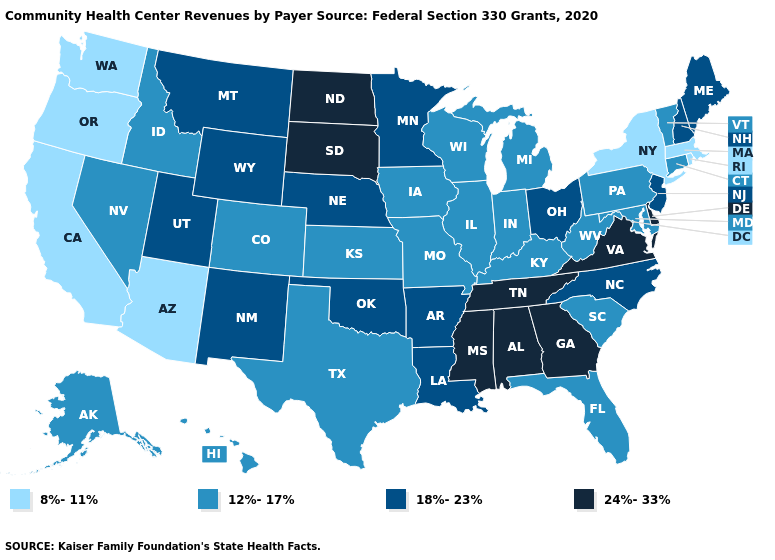Name the states that have a value in the range 12%-17%?
Concise answer only. Alaska, Colorado, Connecticut, Florida, Hawaii, Idaho, Illinois, Indiana, Iowa, Kansas, Kentucky, Maryland, Michigan, Missouri, Nevada, Pennsylvania, South Carolina, Texas, Vermont, West Virginia, Wisconsin. Among the states that border Illinois , which have the lowest value?
Answer briefly. Indiana, Iowa, Kentucky, Missouri, Wisconsin. Does Missouri have the same value as Colorado?
Short answer required. Yes. Name the states that have a value in the range 24%-33%?
Write a very short answer. Alabama, Delaware, Georgia, Mississippi, North Dakota, South Dakota, Tennessee, Virginia. What is the lowest value in the USA?
Quick response, please. 8%-11%. What is the value of Colorado?
Write a very short answer. 12%-17%. Name the states that have a value in the range 8%-11%?
Give a very brief answer. Arizona, California, Massachusetts, New York, Oregon, Rhode Island, Washington. What is the value of Oregon?
Write a very short answer. 8%-11%. Name the states that have a value in the range 24%-33%?
Quick response, please. Alabama, Delaware, Georgia, Mississippi, North Dakota, South Dakota, Tennessee, Virginia. Which states have the highest value in the USA?
Write a very short answer. Alabama, Delaware, Georgia, Mississippi, North Dakota, South Dakota, Tennessee, Virginia. Which states hav the highest value in the West?
Give a very brief answer. Montana, New Mexico, Utah, Wyoming. How many symbols are there in the legend?
Keep it brief. 4. Name the states that have a value in the range 18%-23%?
Concise answer only. Arkansas, Louisiana, Maine, Minnesota, Montana, Nebraska, New Hampshire, New Jersey, New Mexico, North Carolina, Ohio, Oklahoma, Utah, Wyoming. What is the value of Texas?
Concise answer only. 12%-17%. Does Florida have the highest value in the USA?
Keep it brief. No. 